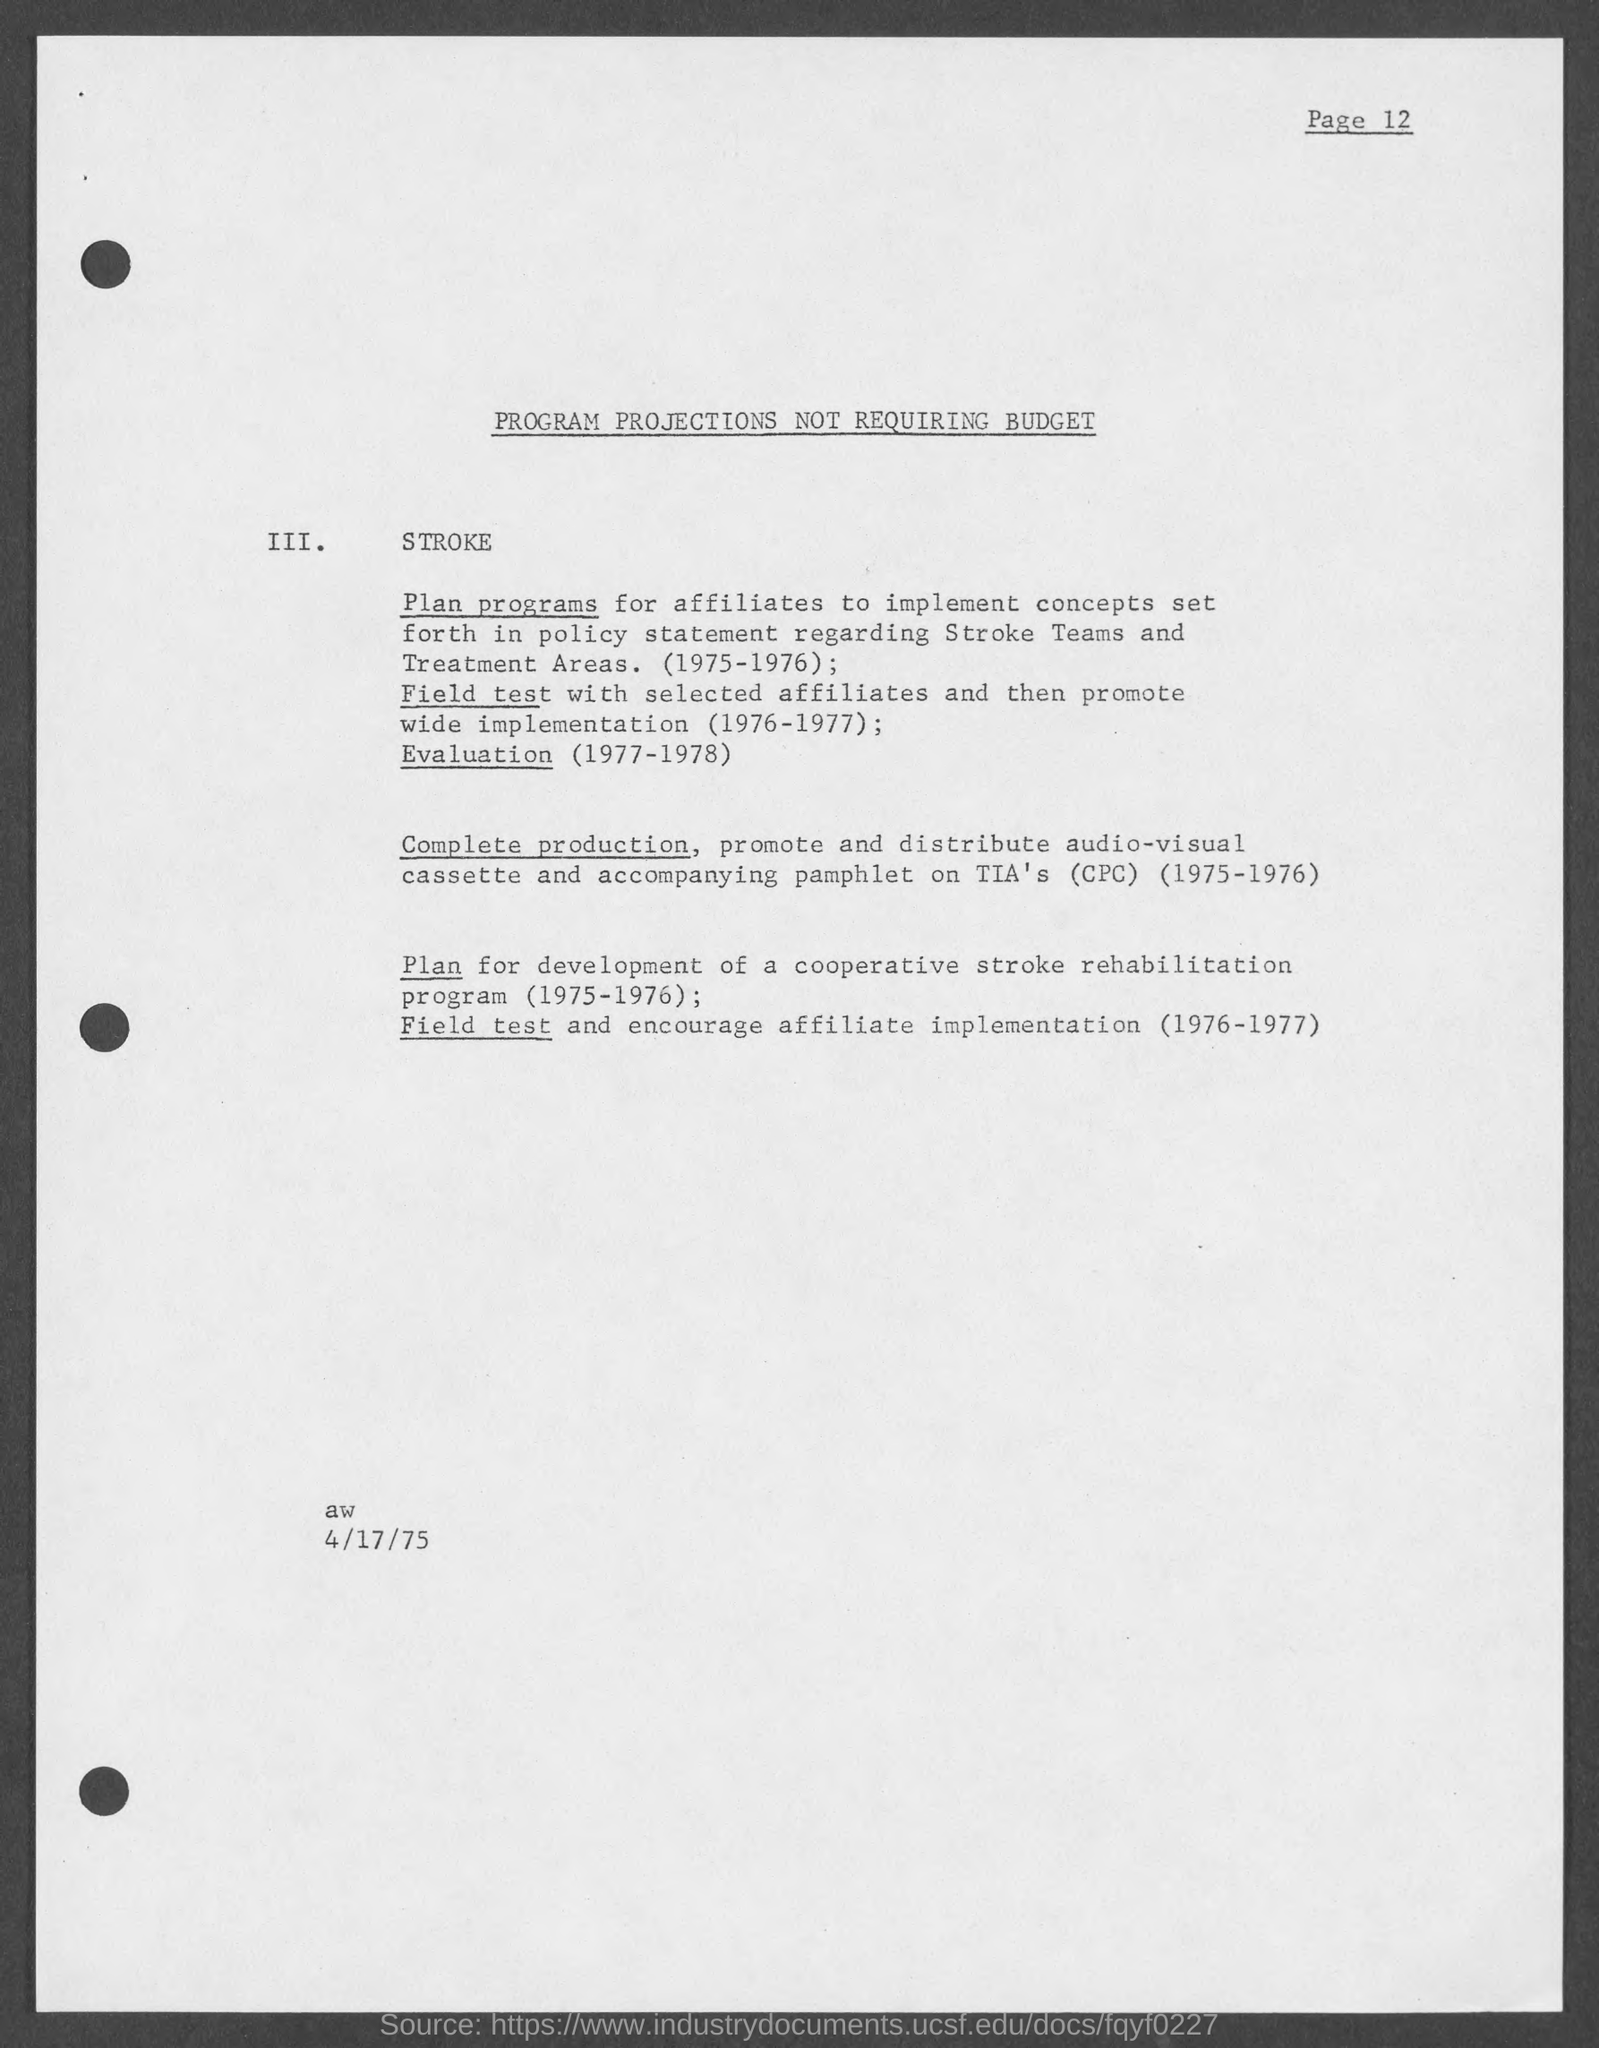What is the document title?
Provide a succinct answer. Program Projections Not Requiring Budget. When is the document dated?
Keep it short and to the point. 4/17/75. 